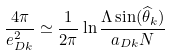<formula> <loc_0><loc_0><loc_500><loc_500>\frac { 4 \pi } { e _ { D k } ^ { 2 } } \simeq \frac { 1 } { 2 \pi } \ln \frac { \Lambda \sin ( \widehat { \theta } _ { k } ) } { a _ { D k } N }</formula> 